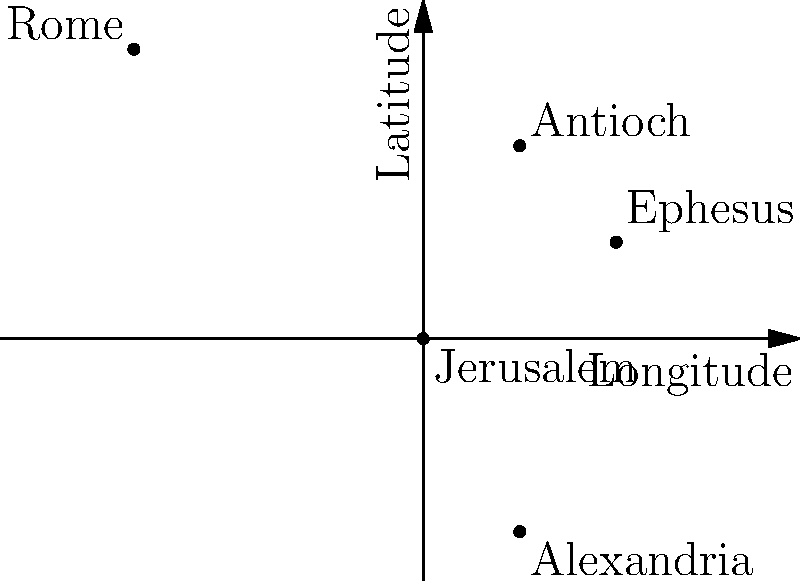On the given coordinate system representing biblical locations, which city is located at approximately (1, 2) and played a crucial role in the early spread of Christianity to the Gentiles? To answer this question, we need to follow these steps:

1. Understand the context: The coordinate system represents important biblical locations related to the spread of early Christianity.

2. Identify the point: We're looking for the city located at coordinates (1, 2).

3. Examine the plot: On the given coordinate system, we can see five labeled cities:
   - Jerusalem at (0, 0)
   - Antioch at (1, 2)
   - Rome at (-3, 3)
   - Alexandria at (1, -2)
   - Ephesus at (2, 1)

4. Match the coordinates: The city located at (1, 2) is Antioch.

5. Historical significance: Antioch played a crucial role in the early spread of Christianity to the Gentiles. It was here that followers of Jesus were first called "Christians" (Acts 11:26). The city became a major center for early Christian missions, particularly through the work of Paul and Barnabas (Acts 13:1-3).

Therefore, the city located at (1, 2) that played a crucial role in the early spread of Christianity to the Gentiles is Antioch.
Answer: Antioch 